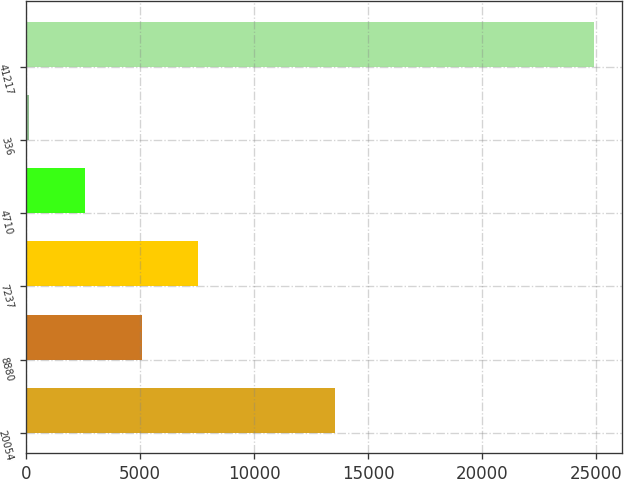Convert chart to OTSL. <chart><loc_0><loc_0><loc_500><loc_500><bar_chart><fcel>20054<fcel>8880<fcel>7237<fcel>4710<fcel>336<fcel>41217<nl><fcel>13539<fcel>5085.8<fcel>7562.7<fcel>2608.9<fcel>132<fcel>24901<nl></chart> 